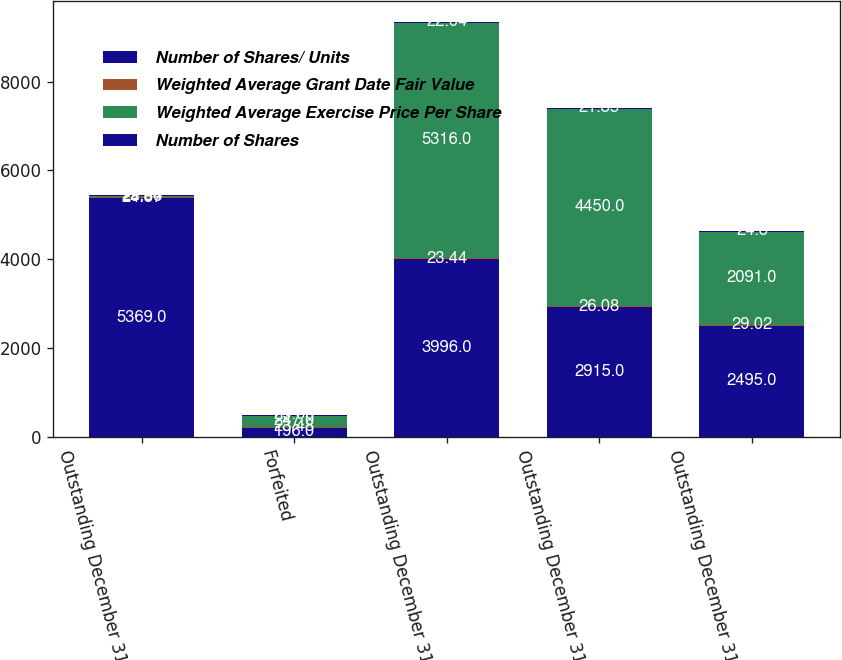<chart> <loc_0><loc_0><loc_500><loc_500><stacked_bar_chart><ecel><fcel>Outstanding December 31 2009<fcel>Forfeited<fcel>Outstanding December 31 2010<fcel>Outstanding December 31 2011<fcel>Outstanding December 31 2012<nl><fcel>Number of Shares/ Units<fcel>5369<fcel>196<fcel>3996<fcel>2915<fcel>2495<nl><fcel>Weighted Average Grant Date Fair Value<fcel>24.87<fcel>23.48<fcel>23.44<fcel>26.08<fcel>29.02<nl><fcel>Weighted Average Exercise Price Per Share<fcel>29.66<fcel>247<fcel>5316<fcel>4450<fcel>2091<nl><fcel>Number of Shares<fcel>22.34<fcel>29.66<fcel>22.04<fcel>21.85<fcel>24.8<nl></chart> 